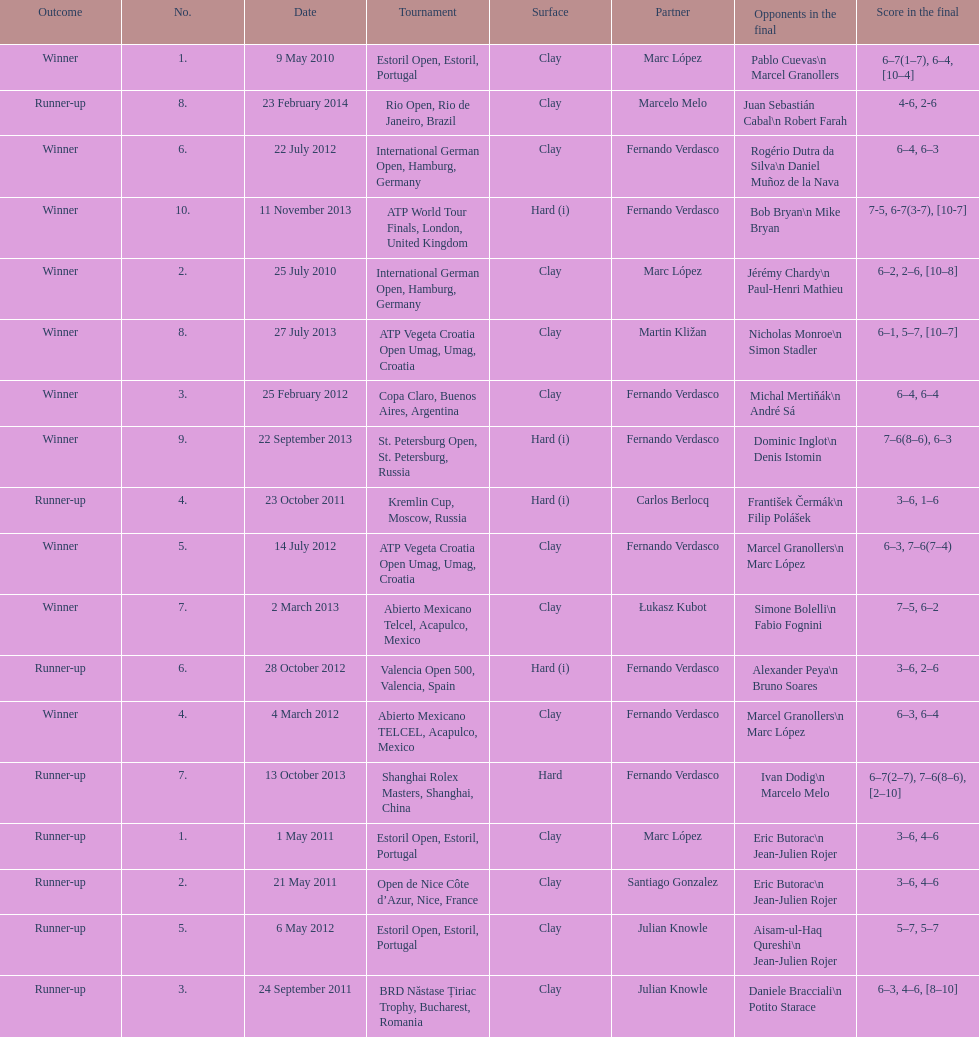What is the total number of runner-ups listed on the chart? 8. 